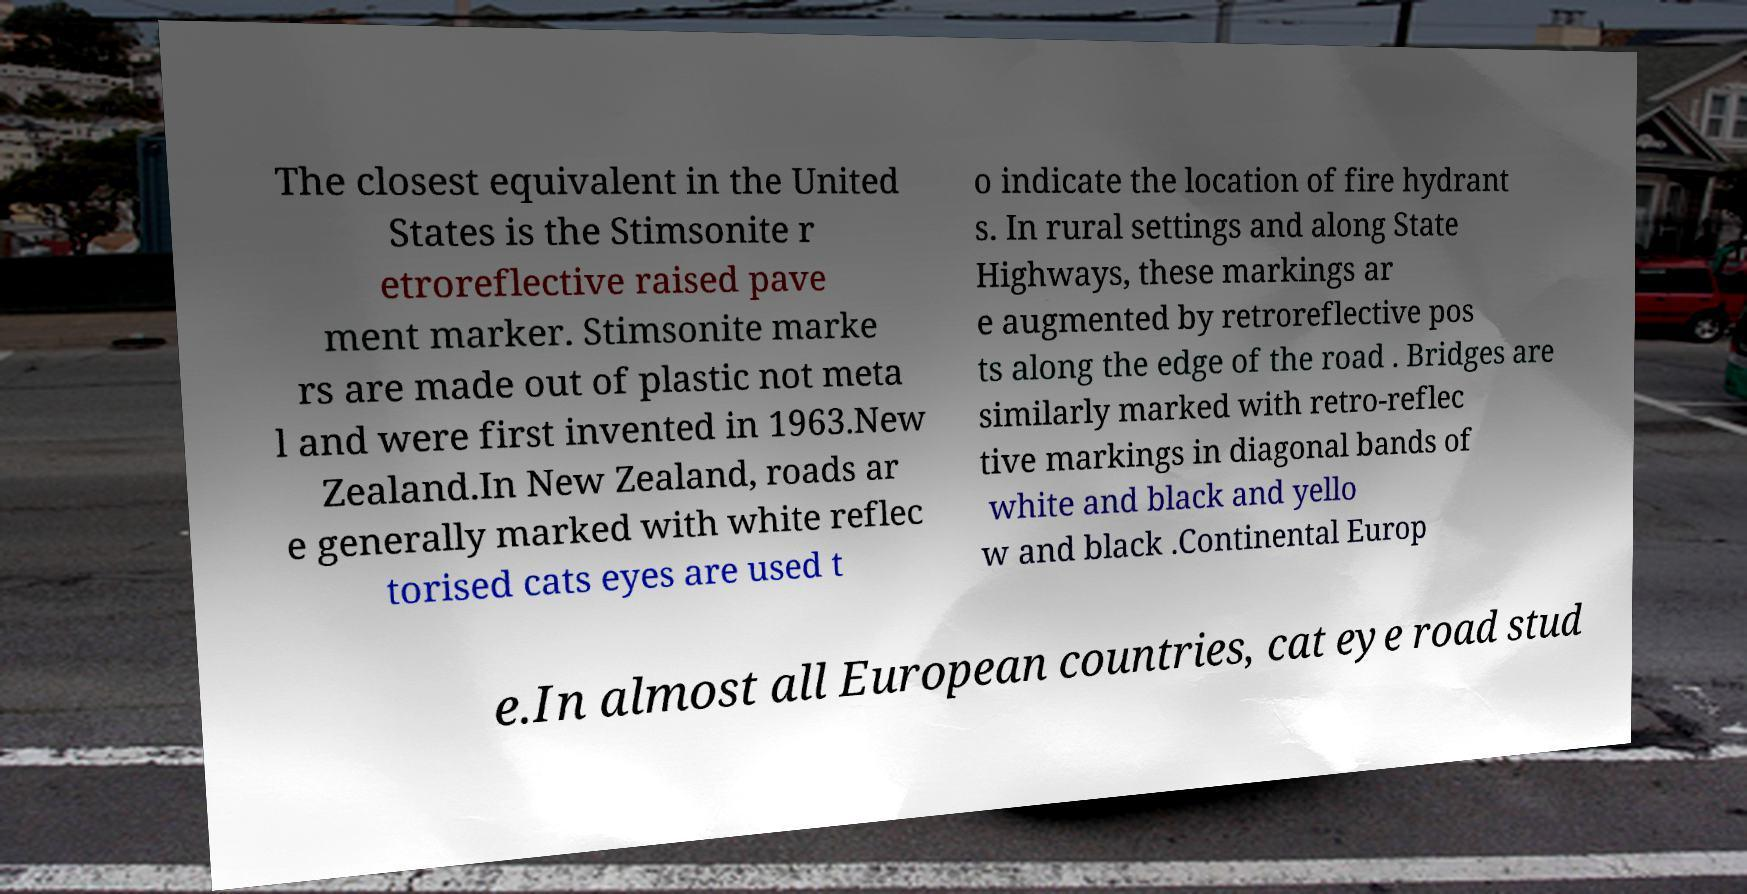Can you accurately transcribe the text from the provided image for me? The closest equivalent in the United States is the Stimsonite r etroreflective raised pave ment marker. Stimsonite marke rs are made out of plastic not meta l and were first invented in 1963.New Zealand.In New Zealand, roads ar e generally marked with white reflec torised cats eyes are used t o indicate the location of fire hydrant s. In rural settings and along State Highways, these markings ar e augmented by retroreflective pos ts along the edge of the road . Bridges are similarly marked with retro-reflec tive markings in diagonal bands of white and black and yello w and black .Continental Europ e.In almost all European countries, cat eye road stud 